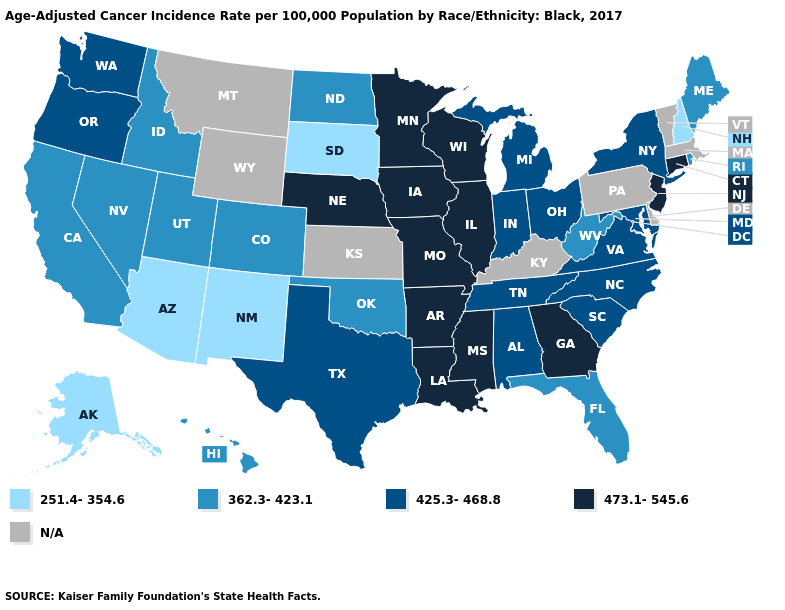Among the states that border Idaho , does Utah have the lowest value?
Short answer required. Yes. How many symbols are there in the legend?
Concise answer only. 5. Does Oregon have the highest value in the West?
Be succinct. Yes. Name the states that have a value in the range 362.3-423.1?
Quick response, please. California, Colorado, Florida, Hawaii, Idaho, Maine, Nevada, North Dakota, Oklahoma, Rhode Island, Utah, West Virginia. Among the states that border Arizona , which have the highest value?
Concise answer only. California, Colorado, Nevada, Utah. What is the value of New Mexico?
Quick response, please. 251.4-354.6. Among the states that border Massachusetts , does Rhode Island have the lowest value?
Give a very brief answer. No. Which states have the highest value in the USA?
Be succinct. Arkansas, Connecticut, Georgia, Illinois, Iowa, Louisiana, Minnesota, Mississippi, Missouri, Nebraska, New Jersey, Wisconsin. What is the lowest value in states that border Alabama?
Be succinct. 362.3-423.1. Which states have the lowest value in the USA?
Write a very short answer. Alaska, Arizona, New Hampshire, New Mexico, South Dakota. Name the states that have a value in the range N/A?
Concise answer only. Delaware, Kansas, Kentucky, Massachusetts, Montana, Pennsylvania, Vermont, Wyoming. What is the value of Idaho?
Answer briefly. 362.3-423.1. 